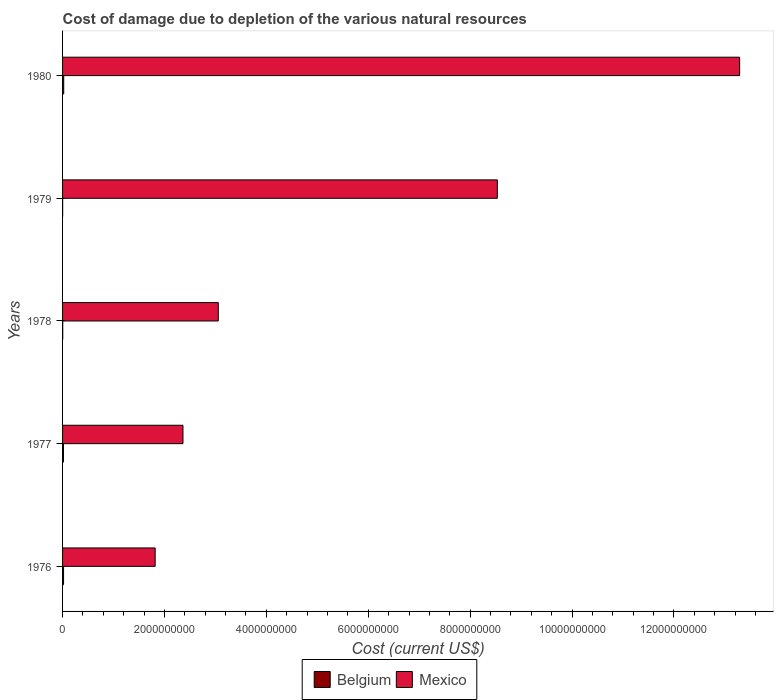Are the number of bars on each tick of the Y-axis equal?
Your answer should be very brief. Yes. How many bars are there on the 5th tick from the bottom?
Offer a terse response. 2. What is the label of the 5th group of bars from the top?
Ensure brevity in your answer.  1976. What is the cost of damage caused due to the depletion of various natural resources in Mexico in 1980?
Ensure brevity in your answer.  1.33e+1. Across all years, what is the maximum cost of damage caused due to the depletion of various natural resources in Belgium?
Offer a terse response. 2.27e+07. Across all years, what is the minimum cost of damage caused due to the depletion of various natural resources in Mexico?
Your response must be concise. 1.82e+09. In which year was the cost of damage caused due to the depletion of various natural resources in Mexico maximum?
Provide a succinct answer. 1980. In which year was the cost of damage caused due to the depletion of various natural resources in Mexico minimum?
Your answer should be very brief. 1976. What is the total cost of damage caused due to the depletion of various natural resources in Belgium in the graph?
Your answer should be very brief. 6.56e+07. What is the difference between the cost of damage caused due to the depletion of various natural resources in Belgium in 1976 and that in 1980?
Your response must be concise. -3.09e+06. What is the difference between the cost of damage caused due to the depletion of various natural resources in Mexico in 1980 and the cost of damage caused due to the depletion of various natural resources in Belgium in 1979?
Your response must be concise. 1.33e+1. What is the average cost of damage caused due to the depletion of various natural resources in Mexico per year?
Offer a terse response. 5.81e+09. In the year 1980, what is the difference between the cost of damage caused due to the depletion of various natural resources in Mexico and cost of damage caused due to the depletion of various natural resources in Belgium?
Your response must be concise. 1.33e+1. In how many years, is the cost of damage caused due to the depletion of various natural resources in Mexico greater than 11200000000 US$?
Give a very brief answer. 1. What is the ratio of the cost of damage caused due to the depletion of various natural resources in Belgium in 1979 to that in 1980?
Your answer should be compact. 0.08. Is the cost of damage caused due to the depletion of various natural resources in Mexico in 1976 less than that in 1977?
Offer a terse response. Yes. What is the difference between the highest and the second highest cost of damage caused due to the depletion of various natural resources in Mexico?
Your answer should be very brief. 4.76e+09. What is the difference between the highest and the lowest cost of damage caused due to the depletion of various natural resources in Mexico?
Your answer should be very brief. 1.15e+1. Is the sum of the cost of damage caused due to the depletion of various natural resources in Belgium in 1977 and 1979 greater than the maximum cost of damage caused due to the depletion of various natural resources in Mexico across all years?
Your response must be concise. No. What does the 1st bar from the top in 1980 represents?
Keep it short and to the point. Mexico. Are all the bars in the graph horizontal?
Your response must be concise. Yes. Where does the legend appear in the graph?
Your answer should be compact. Bottom center. What is the title of the graph?
Offer a terse response. Cost of damage due to depletion of the various natural resources. Does "Tuvalu" appear as one of the legend labels in the graph?
Keep it short and to the point. No. What is the label or title of the X-axis?
Make the answer very short. Cost (current US$). What is the Cost (current US$) in Belgium in 1976?
Offer a very short reply. 1.96e+07. What is the Cost (current US$) of Mexico in 1976?
Keep it short and to the point. 1.82e+09. What is the Cost (current US$) in Belgium in 1977?
Offer a terse response. 1.81e+07. What is the Cost (current US$) in Mexico in 1977?
Give a very brief answer. 2.36e+09. What is the Cost (current US$) in Belgium in 1978?
Your answer should be compact. 3.40e+06. What is the Cost (current US$) in Mexico in 1978?
Your answer should be compact. 3.06e+09. What is the Cost (current US$) in Belgium in 1979?
Keep it short and to the point. 1.85e+06. What is the Cost (current US$) of Mexico in 1979?
Offer a terse response. 8.53e+09. What is the Cost (current US$) of Belgium in 1980?
Give a very brief answer. 2.27e+07. What is the Cost (current US$) of Mexico in 1980?
Your answer should be very brief. 1.33e+1. Across all years, what is the maximum Cost (current US$) of Belgium?
Offer a very short reply. 2.27e+07. Across all years, what is the maximum Cost (current US$) in Mexico?
Provide a short and direct response. 1.33e+1. Across all years, what is the minimum Cost (current US$) in Belgium?
Your answer should be very brief. 1.85e+06. Across all years, what is the minimum Cost (current US$) in Mexico?
Offer a very short reply. 1.82e+09. What is the total Cost (current US$) in Belgium in the graph?
Make the answer very short. 6.56e+07. What is the total Cost (current US$) of Mexico in the graph?
Offer a terse response. 2.91e+1. What is the difference between the Cost (current US$) in Belgium in 1976 and that in 1977?
Your answer should be very brief. 1.53e+06. What is the difference between the Cost (current US$) of Mexico in 1976 and that in 1977?
Provide a succinct answer. -5.46e+08. What is the difference between the Cost (current US$) of Belgium in 1976 and that in 1978?
Offer a very short reply. 1.62e+07. What is the difference between the Cost (current US$) of Mexico in 1976 and that in 1978?
Make the answer very short. -1.24e+09. What is the difference between the Cost (current US$) of Belgium in 1976 and that in 1979?
Offer a very short reply. 1.77e+07. What is the difference between the Cost (current US$) in Mexico in 1976 and that in 1979?
Your answer should be very brief. -6.72e+09. What is the difference between the Cost (current US$) of Belgium in 1976 and that in 1980?
Your response must be concise. -3.09e+06. What is the difference between the Cost (current US$) of Mexico in 1976 and that in 1980?
Your answer should be very brief. -1.15e+1. What is the difference between the Cost (current US$) in Belgium in 1977 and that in 1978?
Make the answer very short. 1.47e+07. What is the difference between the Cost (current US$) in Mexico in 1977 and that in 1978?
Keep it short and to the point. -6.93e+08. What is the difference between the Cost (current US$) in Belgium in 1977 and that in 1979?
Your answer should be very brief. 1.62e+07. What is the difference between the Cost (current US$) in Mexico in 1977 and that in 1979?
Your response must be concise. -6.17e+09. What is the difference between the Cost (current US$) in Belgium in 1977 and that in 1980?
Your answer should be very brief. -4.62e+06. What is the difference between the Cost (current US$) in Mexico in 1977 and that in 1980?
Keep it short and to the point. -1.09e+1. What is the difference between the Cost (current US$) in Belgium in 1978 and that in 1979?
Offer a very short reply. 1.55e+06. What is the difference between the Cost (current US$) in Mexico in 1978 and that in 1979?
Ensure brevity in your answer.  -5.48e+09. What is the difference between the Cost (current US$) of Belgium in 1978 and that in 1980?
Your response must be concise. -1.93e+07. What is the difference between the Cost (current US$) in Mexico in 1978 and that in 1980?
Provide a succinct answer. -1.02e+1. What is the difference between the Cost (current US$) of Belgium in 1979 and that in 1980?
Provide a succinct answer. -2.08e+07. What is the difference between the Cost (current US$) in Mexico in 1979 and that in 1980?
Offer a very short reply. -4.76e+09. What is the difference between the Cost (current US$) in Belgium in 1976 and the Cost (current US$) in Mexico in 1977?
Make the answer very short. -2.34e+09. What is the difference between the Cost (current US$) of Belgium in 1976 and the Cost (current US$) of Mexico in 1978?
Make the answer very short. -3.04e+09. What is the difference between the Cost (current US$) of Belgium in 1976 and the Cost (current US$) of Mexico in 1979?
Offer a terse response. -8.51e+09. What is the difference between the Cost (current US$) of Belgium in 1976 and the Cost (current US$) of Mexico in 1980?
Your answer should be compact. -1.33e+1. What is the difference between the Cost (current US$) in Belgium in 1977 and the Cost (current US$) in Mexico in 1978?
Provide a short and direct response. -3.04e+09. What is the difference between the Cost (current US$) in Belgium in 1977 and the Cost (current US$) in Mexico in 1979?
Keep it short and to the point. -8.52e+09. What is the difference between the Cost (current US$) in Belgium in 1977 and the Cost (current US$) in Mexico in 1980?
Make the answer very short. -1.33e+1. What is the difference between the Cost (current US$) of Belgium in 1978 and the Cost (current US$) of Mexico in 1979?
Provide a succinct answer. -8.53e+09. What is the difference between the Cost (current US$) in Belgium in 1978 and the Cost (current US$) in Mexico in 1980?
Your answer should be compact. -1.33e+1. What is the difference between the Cost (current US$) in Belgium in 1979 and the Cost (current US$) in Mexico in 1980?
Ensure brevity in your answer.  -1.33e+1. What is the average Cost (current US$) of Belgium per year?
Your response must be concise. 1.31e+07. What is the average Cost (current US$) in Mexico per year?
Make the answer very short. 5.81e+09. In the year 1976, what is the difference between the Cost (current US$) in Belgium and Cost (current US$) in Mexico?
Keep it short and to the point. -1.80e+09. In the year 1977, what is the difference between the Cost (current US$) of Belgium and Cost (current US$) of Mexico?
Provide a short and direct response. -2.35e+09. In the year 1978, what is the difference between the Cost (current US$) of Belgium and Cost (current US$) of Mexico?
Offer a very short reply. -3.05e+09. In the year 1979, what is the difference between the Cost (current US$) in Belgium and Cost (current US$) in Mexico?
Give a very brief answer. -8.53e+09. In the year 1980, what is the difference between the Cost (current US$) in Belgium and Cost (current US$) in Mexico?
Your answer should be compact. -1.33e+1. What is the ratio of the Cost (current US$) in Belgium in 1976 to that in 1977?
Your response must be concise. 1.08. What is the ratio of the Cost (current US$) of Mexico in 1976 to that in 1977?
Offer a very short reply. 0.77. What is the ratio of the Cost (current US$) in Belgium in 1976 to that in 1978?
Your answer should be compact. 5.76. What is the ratio of the Cost (current US$) in Mexico in 1976 to that in 1978?
Offer a very short reply. 0.59. What is the ratio of the Cost (current US$) of Belgium in 1976 to that in 1979?
Ensure brevity in your answer.  10.59. What is the ratio of the Cost (current US$) of Mexico in 1976 to that in 1979?
Ensure brevity in your answer.  0.21. What is the ratio of the Cost (current US$) in Belgium in 1976 to that in 1980?
Your response must be concise. 0.86. What is the ratio of the Cost (current US$) in Mexico in 1976 to that in 1980?
Provide a succinct answer. 0.14. What is the ratio of the Cost (current US$) of Belgium in 1977 to that in 1978?
Provide a short and direct response. 5.31. What is the ratio of the Cost (current US$) in Mexico in 1977 to that in 1978?
Offer a terse response. 0.77. What is the ratio of the Cost (current US$) in Belgium in 1977 to that in 1979?
Your answer should be very brief. 9.76. What is the ratio of the Cost (current US$) in Mexico in 1977 to that in 1979?
Your answer should be very brief. 0.28. What is the ratio of the Cost (current US$) of Belgium in 1977 to that in 1980?
Make the answer very short. 0.8. What is the ratio of the Cost (current US$) in Mexico in 1977 to that in 1980?
Give a very brief answer. 0.18. What is the ratio of the Cost (current US$) of Belgium in 1978 to that in 1979?
Your answer should be very brief. 1.84. What is the ratio of the Cost (current US$) of Mexico in 1978 to that in 1979?
Offer a very short reply. 0.36. What is the ratio of the Cost (current US$) in Mexico in 1978 to that in 1980?
Keep it short and to the point. 0.23. What is the ratio of the Cost (current US$) of Belgium in 1979 to that in 1980?
Provide a succinct answer. 0.08. What is the ratio of the Cost (current US$) in Mexico in 1979 to that in 1980?
Give a very brief answer. 0.64. What is the difference between the highest and the second highest Cost (current US$) of Belgium?
Your answer should be compact. 3.09e+06. What is the difference between the highest and the second highest Cost (current US$) in Mexico?
Your response must be concise. 4.76e+09. What is the difference between the highest and the lowest Cost (current US$) of Belgium?
Ensure brevity in your answer.  2.08e+07. What is the difference between the highest and the lowest Cost (current US$) of Mexico?
Provide a succinct answer. 1.15e+1. 